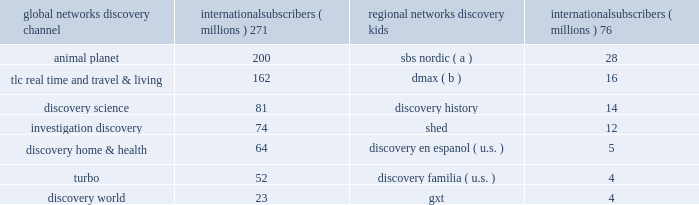Our international networks segment owns and operates the following television networks , which reached the following number of subscribers via pay television services as of december 31 , 2013 : global networks international subscribers ( millions ) regional networks international subscribers ( millions ) .
( a ) number of subscribers corresponds to the collective sum of the total number of subscribers to each of the sbs nordic broadcast networks in sweden , norway , and denmark subject to retransmission agreements with pay television providers .
( b ) number of subscribers corresponds to dmax pay television networks in the u.k. , austria , switzerland and ireland .
Our international networks segment also owns and operates free-to-air television networks which reached 285 million cumulative viewers in europe and the middle east as of december 31 , 2013 .
Our free-to-air networks include dmax , fatafeat , quest , real time , giallo , frisbee , focus and k2 .
Similar to u.s .
Networks , the primary sources of revenue for international networks are fees charged to operators who distribute our networks , which primarily include cable and dth satellite service providers , and advertising sold on our television networks .
International television markets vary in their stages of development .
Some markets , such as the u.k. , are more advanced digital television markets , while others remain in the analog environment with varying degrees of investment from operators to expand channel capacity or convert to digital technologies .
Common practice in some markets results in long-term contractual distribution relationships , while customers in other markets renew contracts annually .
Distribution revenue for our international networks segment is largely dependent on the number of subscribers that receive our networks or content , the rates negotiated in the agreements , and the market demand for the content that we provide .
Advertising revenue is dependent upon a number of factors including the development of pay and free-to-air television markets , the number of subscribers to and viewers of our channels , viewership demographics , the popularity of our programming , and our ability to sell commercial time over a group of channels .
In certain markets , our advertising sales business operates with in-house sales teams , while we rely on external sales representation services in other markets .
In developing television markets , we expect that advertising revenue growth will result from continued subscriber and viewership growth , our localization strategy , and the shift of advertising spending from traditional analog networks to channels in the multi-channel environment .
In relatively mature markets , such as western europe , growth in advertising revenue will come from increasing viewership and pricing of advertising on our existing television networks and the launching of new services , both organic and through acquisitions .
During 2013 , distribution , advertising and other revenues were 50% ( 50 % ) , 47% ( 47 % ) and 3% ( 3 % ) , respectively , of total net revenues for this segment .
On january 21 , 2014 , we entered into an agreement with tf1 to acquire a controlling interest in eurosport international ( "eurosport" ) , a leading pan-european sports media platform , by increasing our ownership stake from 20% ( 20 % ) to 51% ( 51 % ) for cash of approximately 20ac253 million ( $ 343 million ) subject to working capital adjustments .
Due to regulatory constraints the acquisition initially excludes eurosport france , a subsidiary of eurosport .
We will retain a 20% ( 20 % ) equity interest in eurosport france and a commitment to acquire another 31% ( 31 % ) ownership interest beginning 2015 , contingent upon resolution of all regulatory matters .
The flagship eurosport network focuses on regionally popular sports such as tennis , skiing , cycling and motor sports and reaches 133 million homes across 54 countries in 20 languages .
Eurosport 2019s brands and platforms also include eurosport hd ( high definition simulcast ) , eurosport 2 , eurosport 2 hd ( high definition simulcast ) , eurosport asia-pacific , and eurosportnews .
The acquisition is intended to increase the growth of eurosport and enhance our pay television offerings in europe .
Tf1 will have the right to put the entirety of its remaining 49% ( 49 % ) non-controlling interest to us for approximately two and a half years after completion of this acquisition .
The put has a floor value equal to the fair value at the acquisition date if exercised in the 90 day period beginning on july 1 , 2015 and is subsequently priced at fair value if exercised in the 90 day period beginning on july 1 , 2016 .
We expect the acquisition to close in the second quarter of 2014 subject to obtaining necessary regulatory approvals. .
As of january 21 , 2014 , what was the implied total value of eurosport international based on the price paid for the increased ownership , in us$ millions ? 
Computations: (343 / (51% - 20%))
Answer: 1106.45161. Our international networks segment owns and operates the following television networks , which reached the following number of subscribers via pay television services as of december 31 , 2013 : global networks international subscribers ( millions ) regional networks international subscribers ( millions ) .
( a ) number of subscribers corresponds to the collective sum of the total number of subscribers to each of the sbs nordic broadcast networks in sweden , norway , and denmark subject to retransmission agreements with pay television providers .
( b ) number of subscribers corresponds to dmax pay television networks in the u.k. , austria , switzerland and ireland .
Our international networks segment also owns and operates free-to-air television networks which reached 285 million cumulative viewers in europe and the middle east as of december 31 , 2013 .
Our free-to-air networks include dmax , fatafeat , quest , real time , giallo , frisbee , focus and k2 .
Similar to u.s .
Networks , the primary sources of revenue for international networks are fees charged to operators who distribute our networks , which primarily include cable and dth satellite service providers , and advertising sold on our television networks .
International television markets vary in their stages of development .
Some markets , such as the u.k. , are more advanced digital television markets , while others remain in the analog environment with varying degrees of investment from operators to expand channel capacity or convert to digital technologies .
Common practice in some markets results in long-term contractual distribution relationships , while customers in other markets renew contracts annually .
Distribution revenue for our international networks segment is largely dependent on the number of subscribers that receive our networks or content , the rates negotiated in the agreements , and the market demand for the content that we provide .
Advertising revenue is dependent upon a number of factors including the development of pay and free-to-air television markets , the number of subscribers to and viewers of our channels , viewership demographics , the popularity of our programming , and our ability to sell commercial time over a group of channels .
In certain markets , our advertising sales business operates with in-house sales teams , while we rely on external sales representation services in other markets .
In developing television markets , we expect that advertising revenue growth will result from continued subscriber and viewership growth , our localization strategy , and the shift of advertising spending from traditional analog networks to channels in the multi-channel environment .
In relatively mature markets , such as western europe , growth in advertising revenue will come from increasing viewership and pricing of advertising on our existing television networks and the launching of new services , both organic and through acquisitions .
During 2013 , distribution , advertising and other revenues were 50% ( 50 % ) , 47% ( 47 % ) and 3% ( 3 % ) , respectively , of total net revenues for this segment .
On january 21 , 2014 , we entered into an agreement with tf1 to acquire a controlling interest in eurosport international ( "eurosport" ) , a leading pan-european sports media platform , by increasing our ownership stake from 20% ( 20 % ) to 51% ( 51 % ) for cash of approximately 20ac253 million ( $ 343 million ) subject to working capital adjustments .
Due to regulatory constraints the acquisition initially excludes eurosport france , a subsidiary of eurosport .
We will retain a 20% ( 20 % ) equity interest in eurosport france and a commitment to acquire another 31% ( 31 % ) ownership interest beginning 2015 , contingent upon resolution of all regulatory matters .
The flagship eurosport network focuses on regionally popular sports such as tennis , skiing , cycling and motor sports and reaches 133 million homes across 54 countries in 20 languages .
Eurosport 2019s brands and platforms also include eurosport hd ( high definition simulcast ) , eurosport 2 , eurosport 2 hd ( high definition simulcast ) , eurosport asia-pacific , and eurosportnews .
The acquisition is intended to increase the growth of eurosport and enhance our pay television offerings in europe .
Tf1 will have the right to put the entirety of its remaining 49% ( 49 % ) non-controlling interest to us for approximately two and a half years after completion of this acquisition .
The put has a floor value equal to the fair value at the acquisition date if exercised in the 90 day period beginning on july 1 , 2015 and is subsequently priced at fair value if exercised in the 90 day period beginning on july 1 , 2016 .
We expect the acquisition to close in the second quarter of 2014 subject to obtaining necessary regulatory approvals. .
What was the difference in millions of international subscribers between discovery channel and animal planet? 
Computations: (271 - 200)
Answer: 71.0. 